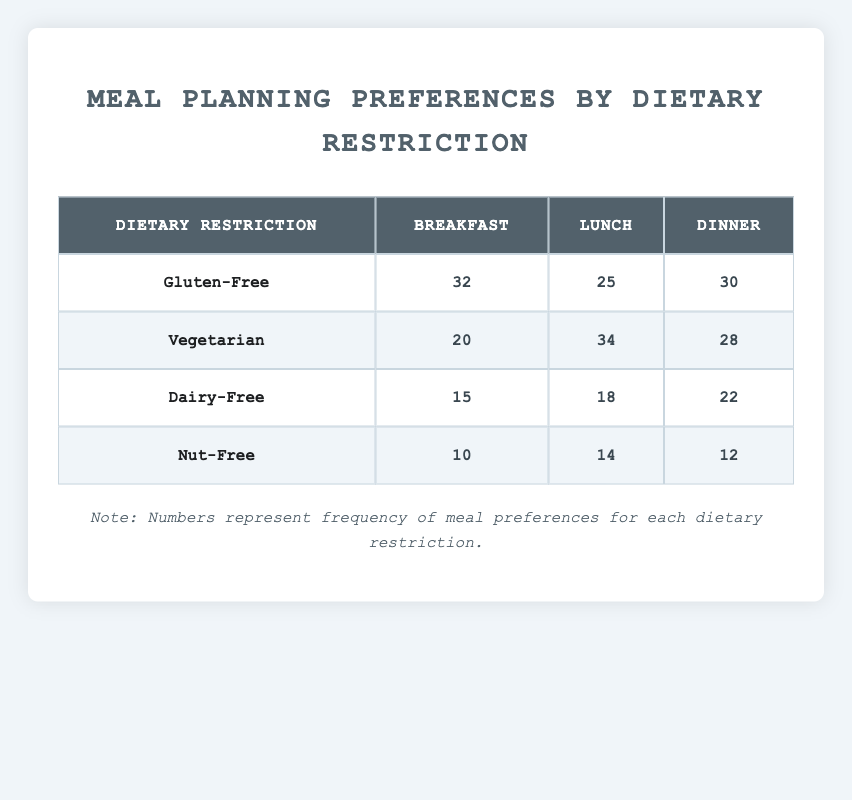What is the most preferred meal for individuals with a Gluten-Free restriction? The highest frequency value under the "Gluten-Free" row is for "Breakfast" with a frequency of 32.
Answer: Breakfast Which meal has the lowest frequency among individuals with a Dairy-Free restriction? Looking at the "Dairy-Free" row, the meal with the lowest frequency is "Breakfast," which has a frequency of 15.
Answer: Breakfast What is the total frequency of meal preferences for Vegetarian individuals? To find the total, we add the frequency values for "Breakfast" (20), "Lunch" (34), and "Dinner" (28): 20 + 34 + 28 = 82.
Answer: 82 Is the frequency of preferred meals higher for Lunch compared to Dinner across all dietary restrictions? For Lunch, the frequencies are 25 (Gluten-Free), 34 (Vegetarian), 18 (Dairy-Free), and 14 (Nut-Free). Summing these gives 25 + 34 + 18 + 14 = 91. For Dinner, the total is 30 (Gluten-Free), 28 (Vegetarian), 22 (Dairy-Free), and 12 (Nut-Free) which totals 30 + 28 + 22 + 12 = 92. Since 91 < 92, the answer is no.
Answer: No What is the average preference frequency for Breakfast meals across all dietary restrictions? To calculate the average, we first sum the frequencies for Breakfast: 32 (Gluten-Free) + 20 (Vegetarian) + 15 (Dairy-Free) + 10 (Nut-Free) = 77. Since there are 4 dietary restrictions, we divide 77 by 4, resulting in 77/4 = 19.25.
Answer: 19.25 